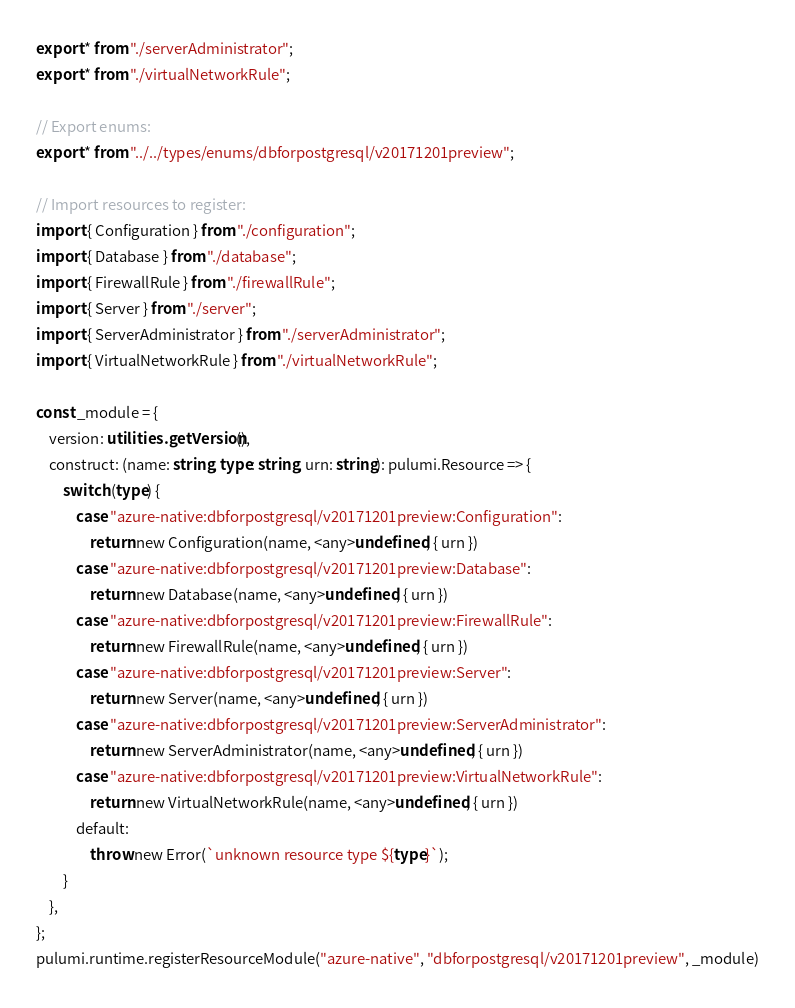Convert code to text. <code><loc_0><loc_0><loc_500><loc_500><_TypeScript_>export * from "./serverAdministrator";
export * from "./virtualNetworkRule";

// Export enums:
export * from "../../types/enums/dbforpostgresql/v20171201preview";

// Import resources to register:
import { Configuration } from "./configuration";
import { Database } from "./database";
import { FirewallRule } from "./firewallRule";
import { Server } from "./server";
import { ServerAdministrator } from "./serverAdministrator";
import { VirtualNetworkRule } from "./virtualNetworkRule";

const _module = {
    version: utilities.getVersion(),
    construct: (name: string, type: string, urn: string): pulumi.Resource => {
        switch (type) {
            case "azure-native:dbforpostgresql/v20171201preview:Configuration":
                return new Configuration(name, <any>undefined, { urn })
            case "azure-native:dbforpostgresql/v20171201preview:Database":
                return new Database(name, <any>undefined, { urn })
            case "azure-native:dbforpostgresql/v20171201preview:FirewallRule":
                return new FirewallRule(name, <any>undefined, { urn })
            case "azure-native:dbforpostgresql/v20171201preview:Server":
                return new Server(name, <any>undefined, { urn })
            case "azure-native:dbforpostgresql/v20171201preview:ServerAdministrator":
                return new ServerAdministrator(name, <any>undefined, { urn })
            case "azure-native:dbforpostgresql/v20171201preview:VirtualNetworkRule":
                return new VirtualNetworkRule(name, <any>undefined, { urn })
            default:
                throw new Error(`unknown resource type ${type}`);
        }
    },
};
pulumi.runtime.registerResourceModule("azure-native", "dbforpostgresql/v20171201preview", _module)
</code> 